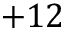<formula> <loc_0><loc_0><loc_500><loc_500>+ 1 2</formula> 